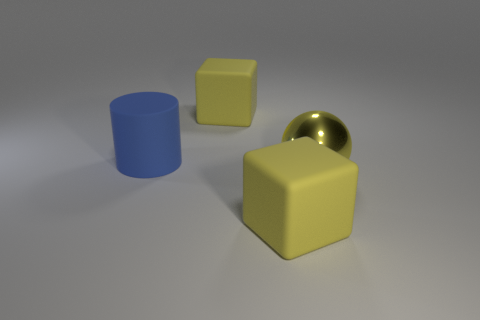What number of other things are the same size as the blue matte thing?
Your answer should be very brief. 3. Are the block that is in front of the metallic sphere and the large sphere that is in front of the large matte cylinder made of the same material?
Your response must be concise. No. Is there a metallic thing that has the same color as the large sphere?
Your answer should be very brief. No. There is a large matte block behind the big cylinder; does it have the same color as the block in front of the large metal ball?
Offer a very short reply. Yes. The large blue matte thing has what shape?
Keep it short and to the point. Cylinder. There is a big yellow shiny thing; how many large yellow blocks are in front of it?
Offer a terse response. 1. How many objects have the same material as the blue cylinder?
Your answer should be compact. 2. Is the material of the big yellow block behind the blue rubber object the same as the blue cylinder?
Ensure brevity in your answer.  Yes. Are any big blue metal blocks visible?
Your answer should be compact. No. Are there more objects that are left of the big shiny sphere than large blue cylinders that are in front of the large rubber cylinder?
Your answer should be very brief. Yes. 